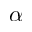Convert formula to latex. <formula><loc_0><loc_0><loc_500><loc_500>\alpha</formula> 